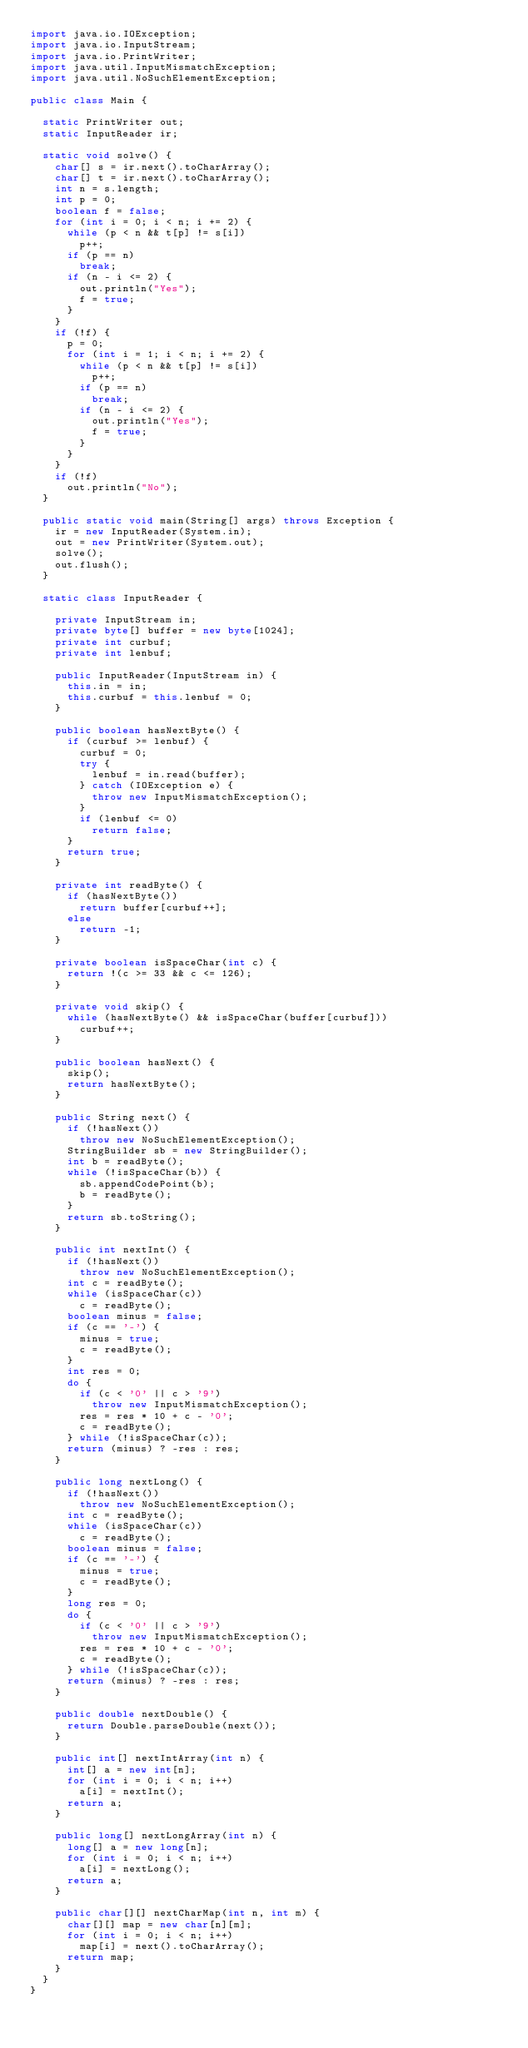<code> <loc_0><loc_0><loc_500><loc_500><_Java_>import java.io.IOException;
import java.io.InputStream;
import java.io.PrintWriter;
import java.util.InputMismatchException;
import java.util.NoSuchElementException;

public class Main {

	static PrintWriter out;
	static InputReader ir;

	static void solve() {
		char[] s = ir.next().toCharArray();
		char[] t = ir.next().toCharArray();
		int n = s.length;
		int p = 0;
		boolean f = false;
		for (int i = 0; i < n; i += 2) {
			while (p < n && t[p] != s[i])
				p++;
			if (p == n)
				break;
			if (n - i <= 2) {
				out.println("Yes");
				f = true;
			}
		}
		if (!f) {
			p = 0;
			for (int i = 1; i < n; i += 2) {
				while (p < n && t[p] != s[i])
					p++;
				if (p == n)
					break;
				if (n - i <= 2) {
					out.println("Yes");
					f = true;
				}
			}
		}
		if (!f)
			out.println("No");
	}

	public static void main(String[] args) throws Exception {
		ir = new InputReader(System.in);
		out = new PrintWriter(System.out);
		solve();
		out.flush();
	}

	static class InputReader {

		private InputStream in;
		private byte[] buffer = new byte[1024];
		private int curbuf;
		private int lenbuf;

		public InputReader(InputStream in) {
			this.in = in;
			this.curbuf = this.lenbuf = 0;
		}

		public boolean hasNextByte() {
			if (curbuf >= lenbuf) {
				curbuf = 0;
				try {
					lenbuf = in.read(buffer);
				} catch (IOException e) {
					throw new InputMismatchException();
				}
				if (lenbuf <= 0)
					return false;
			}
			return true;
		}

		private int readByte() {
			if (hasNextByte())
				return buffer[curbuf++];
			else
				return -1;
		}

		private boolean isSpaceChar(int c) {
			return !(c >= 33 && c <= 126);
		}

		private void skip() {
			while (hasNextByte() && isSpaceChar(buffer[curbuf]))
				curbuf++;
		}

		public boolean hasNext() {
			skip();
			return hasNextByte();
		}

		public String next() {
			if (!hasNext())
				throw new NoSuchElementException();
			StringBuilder sb = new StringBuilder();
			int b = readByte();
			while (!isSpaceChar(b)) {
				sb.appendCodePoint(b);
				b = readByte();
			}
			return sb.toString();
		}

		public int nextInt() {
			if (!hasNext())
				throw new NoSuchElementException();
			int c = readByte();
			while (isSpaceChar(c))
				c = readByte();
			boolean minus = false;
			if (c == '-') {
				minus = true;
				c = readByte();
			}
			int res = 0;
			do {
				if (c < '0' || c > '9')
					throw new InputMismatchException();
				res = res * 10 + c - '0';
				c = readByte();
			} while (!isSpaceChar(c));
			return (minus) ? -res : res;
		}

		public long nextLong() {
			if (!hasNext())
				throw new NoSuchElementException();
			int c = readByte();
			while (isSpaceChar(c))
				c = readByte();
			boolean minus = false;
			if (c == '-') {
				minus = true;
				c = readByte();
			}
			long res = 0;
			do {
				if (c < '0' || c > '9')
					throw new InputMismatchException();
				res = res * 10 + c - '0';
				c = readByte();
			} while (!isSpaceChar(c));
			return (minus) ? -res : res;
		}

		public double nextDouble() {
			return Double.parseDouble(next());
		}

		public int[] nextIntArray(int n) {
			int[] a = new int[n];
			for (int i = 0; i < n; i++)
				a[i] = nextInt();
			return a;
		}

		public long[] nextLongArray(int n) {
			long[] a = new long[n];
			for (int i = 0; i < n; i++)
				a[i] = nextLong();
			return a;
		}

		public char[][] nextCharMap(int n, int m) {
			char[][] map = new char[n][m];
			for (int i = 0; i < n; i++)
				map[i] = next().toCharArray();
			return map;
		}
	}
}</code> 